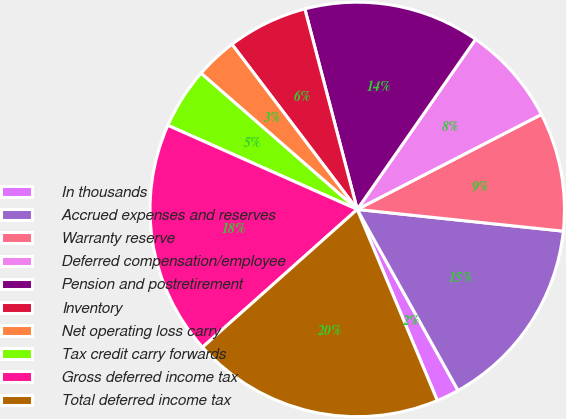Convert chart to OTSL. <chart><loc_0><loc_0><loc_500><loc_500><pie_chart><fcel>In thousands<fcel>Accrued expenses and reserves<fcel>Warranty reserve<fcel>Deferred compensation/employee<fcel>Pension and postretirement<fcel>Inventory<fcel>Net operating loss carry<fcel>Tax credit carry forwards<fcel>Gross deferred income tax<fcel>Total deferred income tax<nl><fcel>1.77%<fcel>15.24%<fcel>9.25%<fcel>7.75%<fcel>13.74%<fcel>6.26%<fcel>3.26%<fcel>4.76%<fcel>18.23%<fcel>19.73%<nl></chart> 